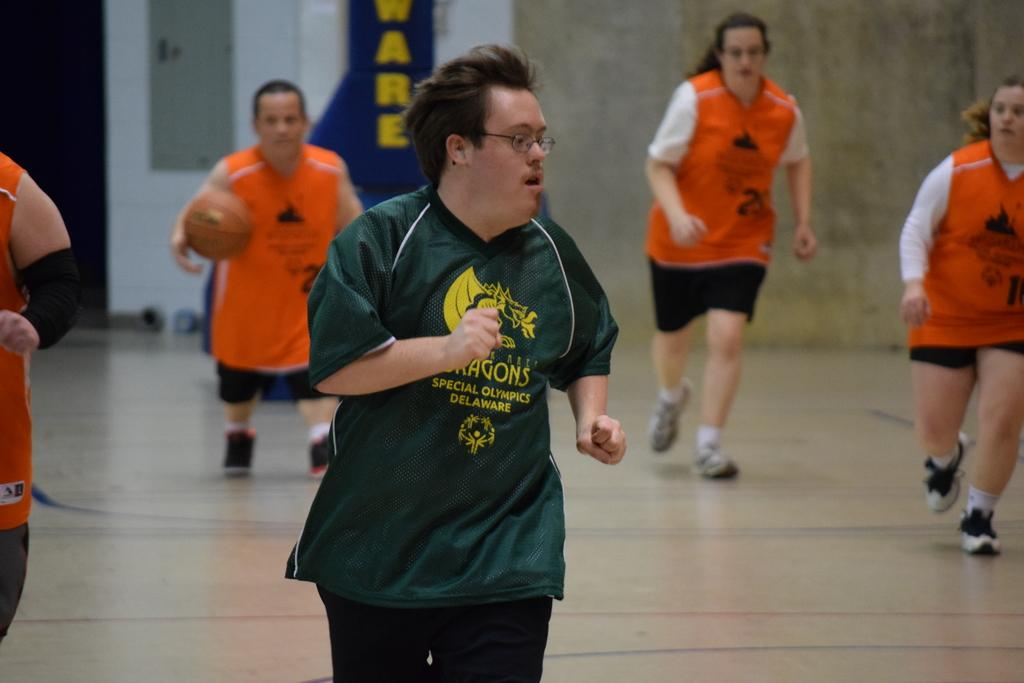How many people are in the image? There is a group of people in the image. What are the people in the image doing? The people are on the floor. What object is one person holding? One person is holding a ball. What can be seen in the background of the image? There is a wall and objects visible in the background. How many cakes are being served on the earth in the image? There is no reference to cakes or the earth in the image, so it is not possible to answer that question. 